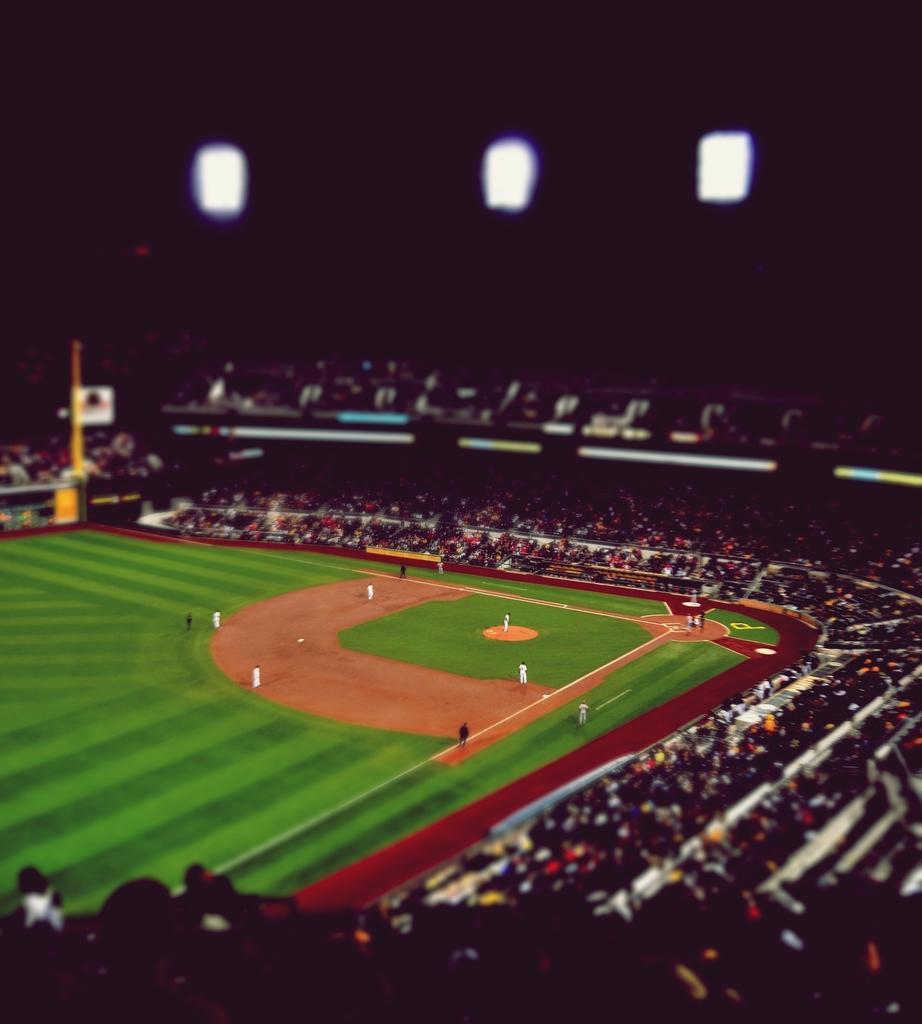Could you give a brief overview of what you see in this image? This is a baseball ground. I can see few people standing in the ground. There are groups of people sitting and standing. This looks like a pole. 